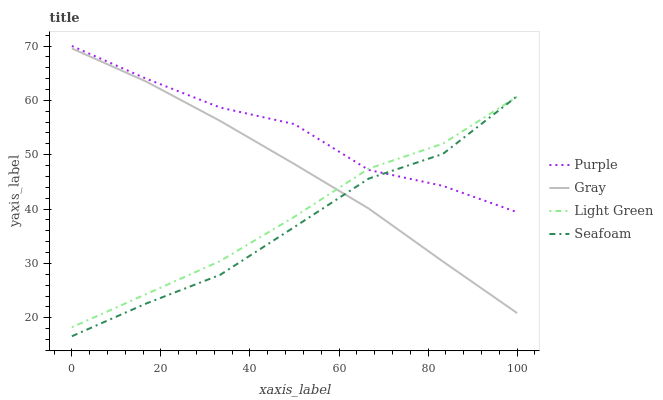Does Gray have the minimum area under the curve?
Answer yes or no. No. Does Gray have the maximum area under the curve?
Answer yes or no. No. Is Seafoam the smoothest?
Answer yes or no. No. Is Seafoam the roughest?
Answer yes or no. No. Does Gray have the lowest value?
Answer yes or no. No. Does Gray have the highest value?
Answer yes or no. No. Is Gray less than Purple?
Answer yes or no. Yes. Is Purple greater than Gray?
Answer yes or no. Yes. Does Gray intersect Purple?
Answer yes or no. No. 